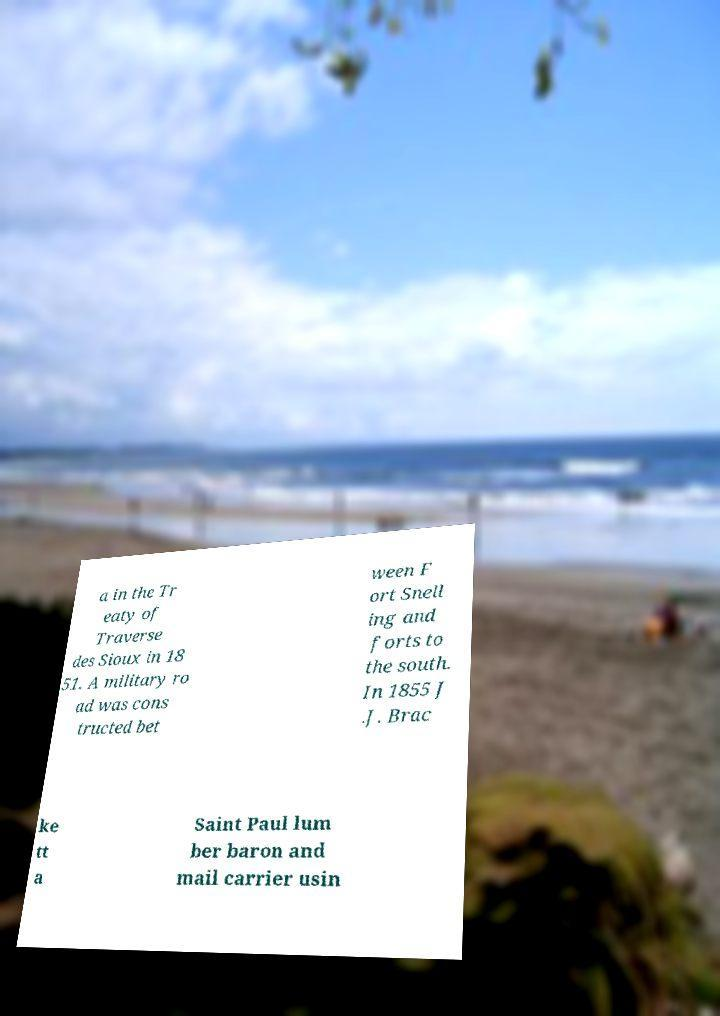Please identify and transcribe the text found in this image. a in the Tr eaty of Traverse des Sioux in 18 51. A military ro ad was cons tructed bet ween F ort Snell ing and forts to the south. In 1855 J .J. Brac ke tt a Saint Paul lum ber baron and mail carrier usin 